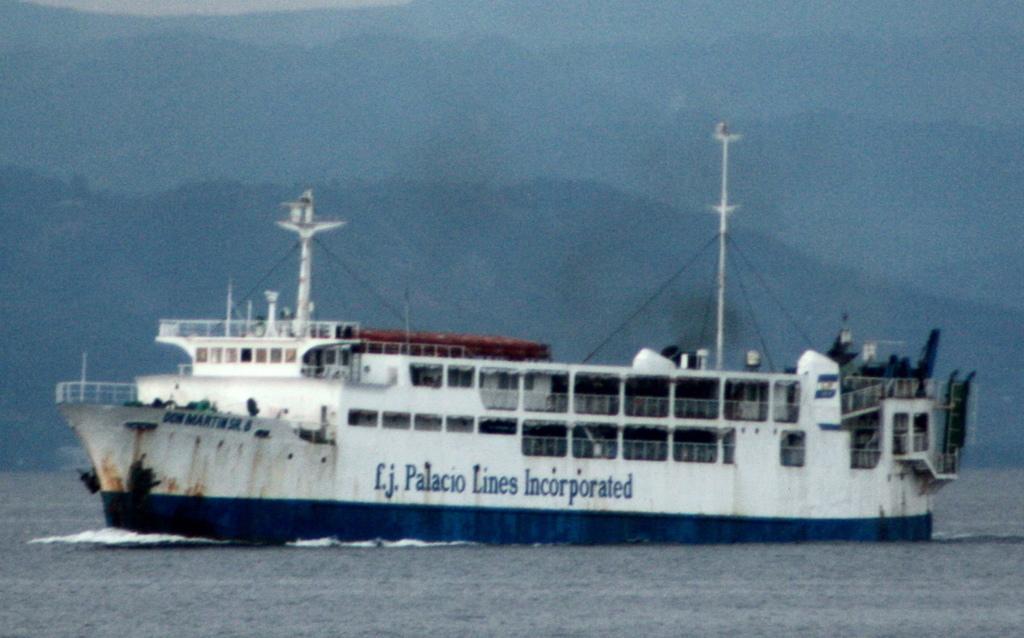Can you describe this image briefly? Background portion of the picture is blurry and we can see the hills. This picture is mainly highlighted with a ship and we can see there is something written on the ship. At the bottom portion of the picture we can see the water. 